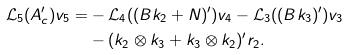Convert formula to latex. <formula><loc_0><loc_0><loc_500><loc_500>\mathcal { L } _ { 5 } ( { A } _ { c } ^ { \prime } ) { v } _ { 5 } = & - \mathcal { L } _ { 4 } ( ( { B } { k } _ { 2 } + { N } ) ^ { \prime } ) { v } _ { 4 } - \mathcal { L } _ { 3 } ( ( { B } { k } _ { 3 } ) ^ { \prime } ) { v } _ { 3 } \\ & - ( { k } _ { 2 } \otimes { k } _ { 3 } + { k } _ { 3 } \otimes { k } _ { 2 } ) ^ { \prime } { r } _ { 2 } .</formula> 